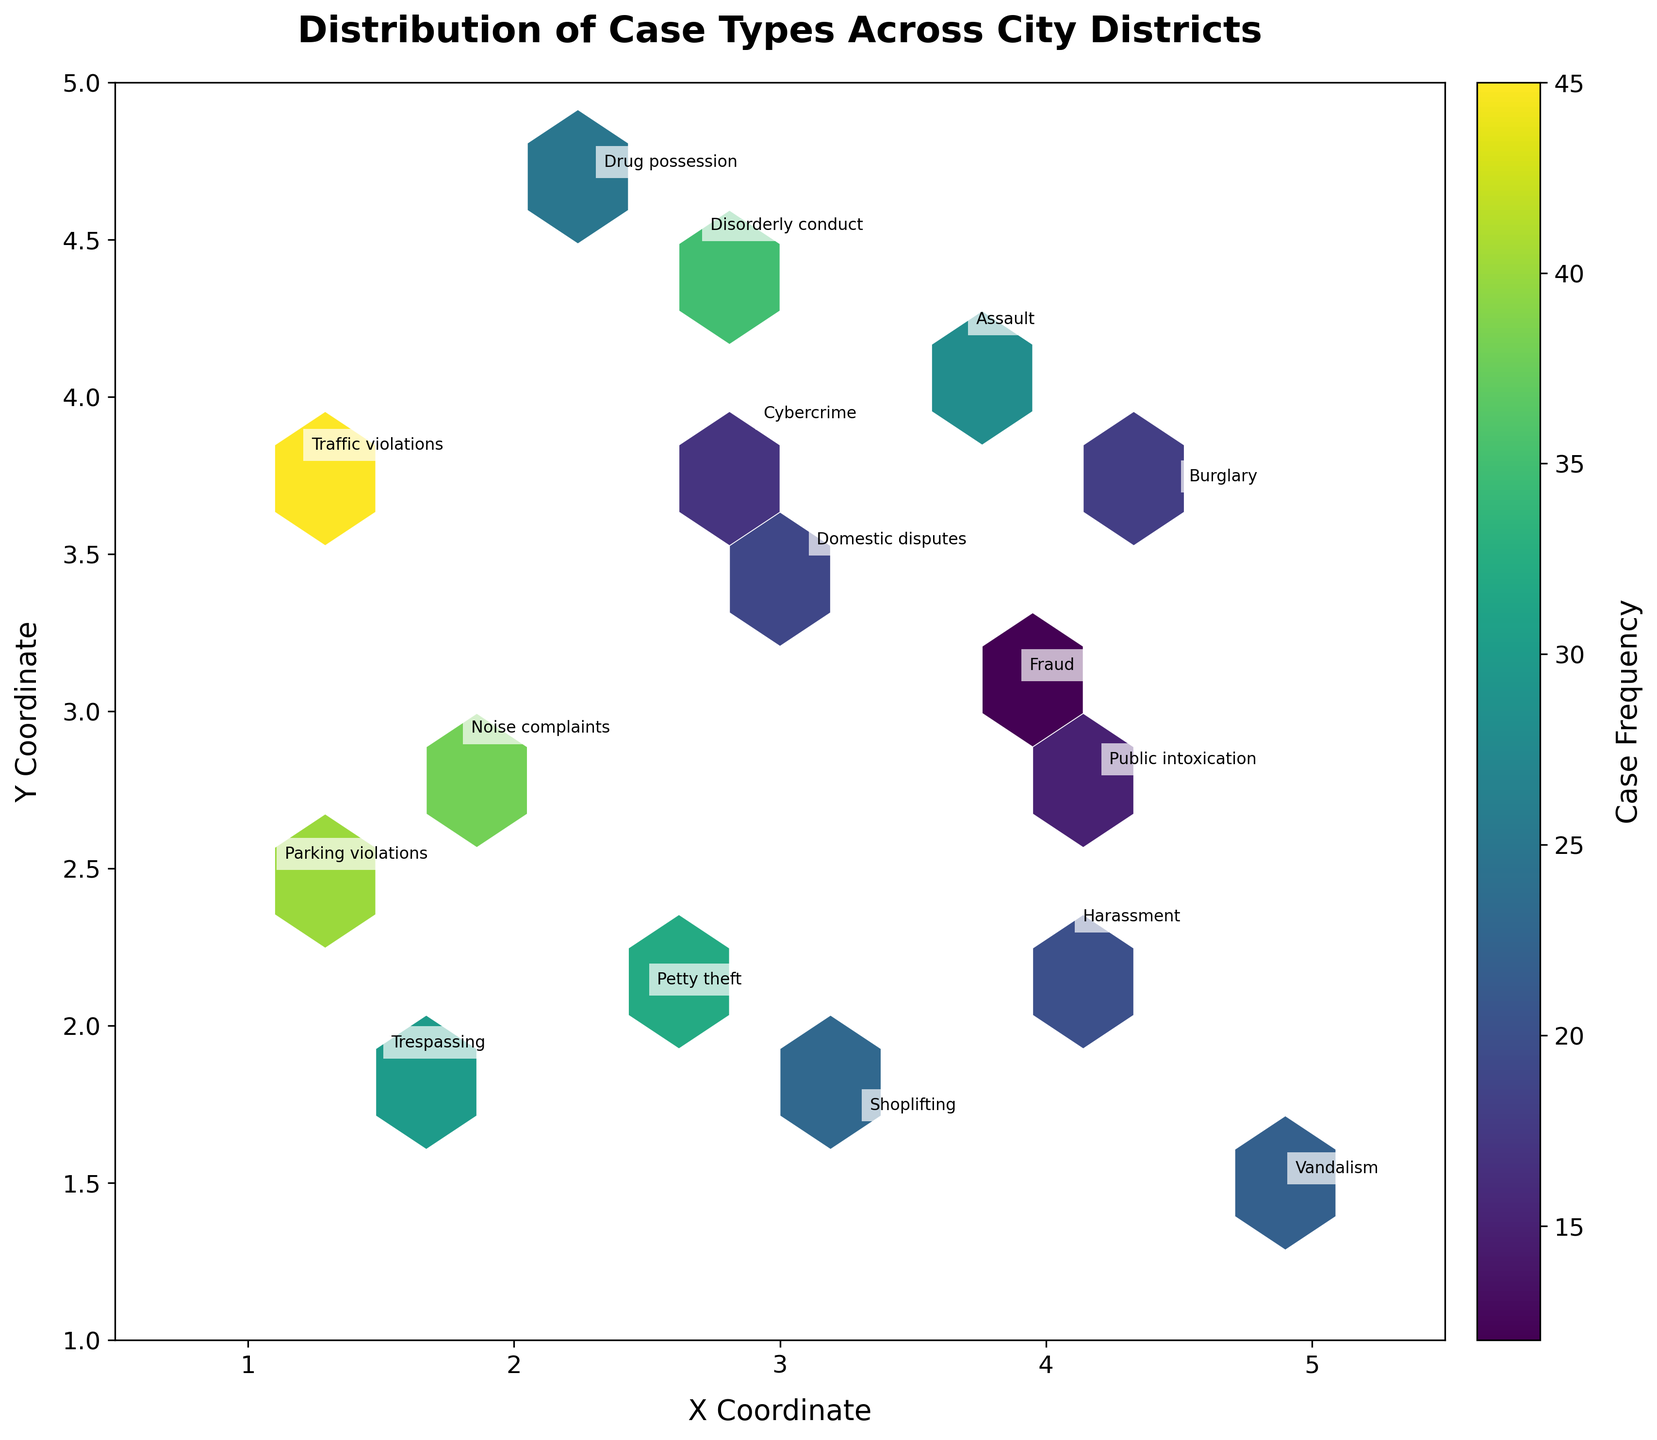What case type appears the most frequently in Downtown? The plot's annotations show that 'Traffic violations' is situated in Downtown and has a frequency of 45, which is the highest among those in Downtown.
Answer: Traffic violations What is the case frequency for Assault in Riverside? The plot shows an annotation for 'Assault' in Riverside with a frequency of 28.
Answer: 28 Which district has the highest number of Petty Theft cases? Midtown appears with the 'Petty theft' annotation, and the frequency used in the Hexbin plot indicates the count of 32.
Answer: Midtown How many types of cases have frequencies greater than 30? By looking at the frequencies of each case type annotation in the plot, 'Traffic violations' (45), 'Trespassing' (30), 'Petty theft' (32), 'Noise complaints' (38), and 'Parking violations' (40) have frequencies greater than 30. That amounts to 5 case types.
Answer: 5 Between 'Drug possession' in Southside and 'Burglary' in the Suburbs, which has a lower frequency? The plot indicates 'Drug possession' in Southside with 25 and 'Burglary' in the Suburbs with a frequency of 18. Therefore, 'Burglary' has a lower frequency.
Answer: Burglary Which case type has the lowest frequency and what is the frequency? By examining the annotated cases, 'Fraud' in the Financial District has the lowest frequency, which is 12.
Answer: Fraud What is the sum of the frequencies for case types in districts located on the plot between x values 1 and 2? The districts are Downtown (Traffic violations, 45), Westend (Noise complaints, 38), Industrial Park (Trespassing, 30), and Shopping District (Parking violations, 40). Summing all frequencies: 45 + 38 + 30 + 40 = 153.
Answer: 153 What color represents the highest case frequencies on the color bar? Looking at the color bar, the color map 'viridis' used indicates that the highest case frequencies are shown in yellow.
Answer: Yellow What is the relationship between the case frequencies of 'Domestic disputes' in Northside and 'Cybercrime' in Tech Hub? The plot shows 'Domestic disputes' with a frequency of 19 and 'Cybercrime' with a frequency of 17. Therefore, 'Domestic disputes' frequency is higher than 'Cybercrime'.
Answer: Domestic disputes are more frequent How many case types are annotated in regions where x and y are both greater than 3? The case types in regions where both x and y coordinates are greater than 3 are 'Assault' (x=3.7, y=4.2), 'Disorderly conduct' (x=2.7, y=4.5 which doesn't count as x < 3), so only "Assault" meets the criteria.
Answer: 1 